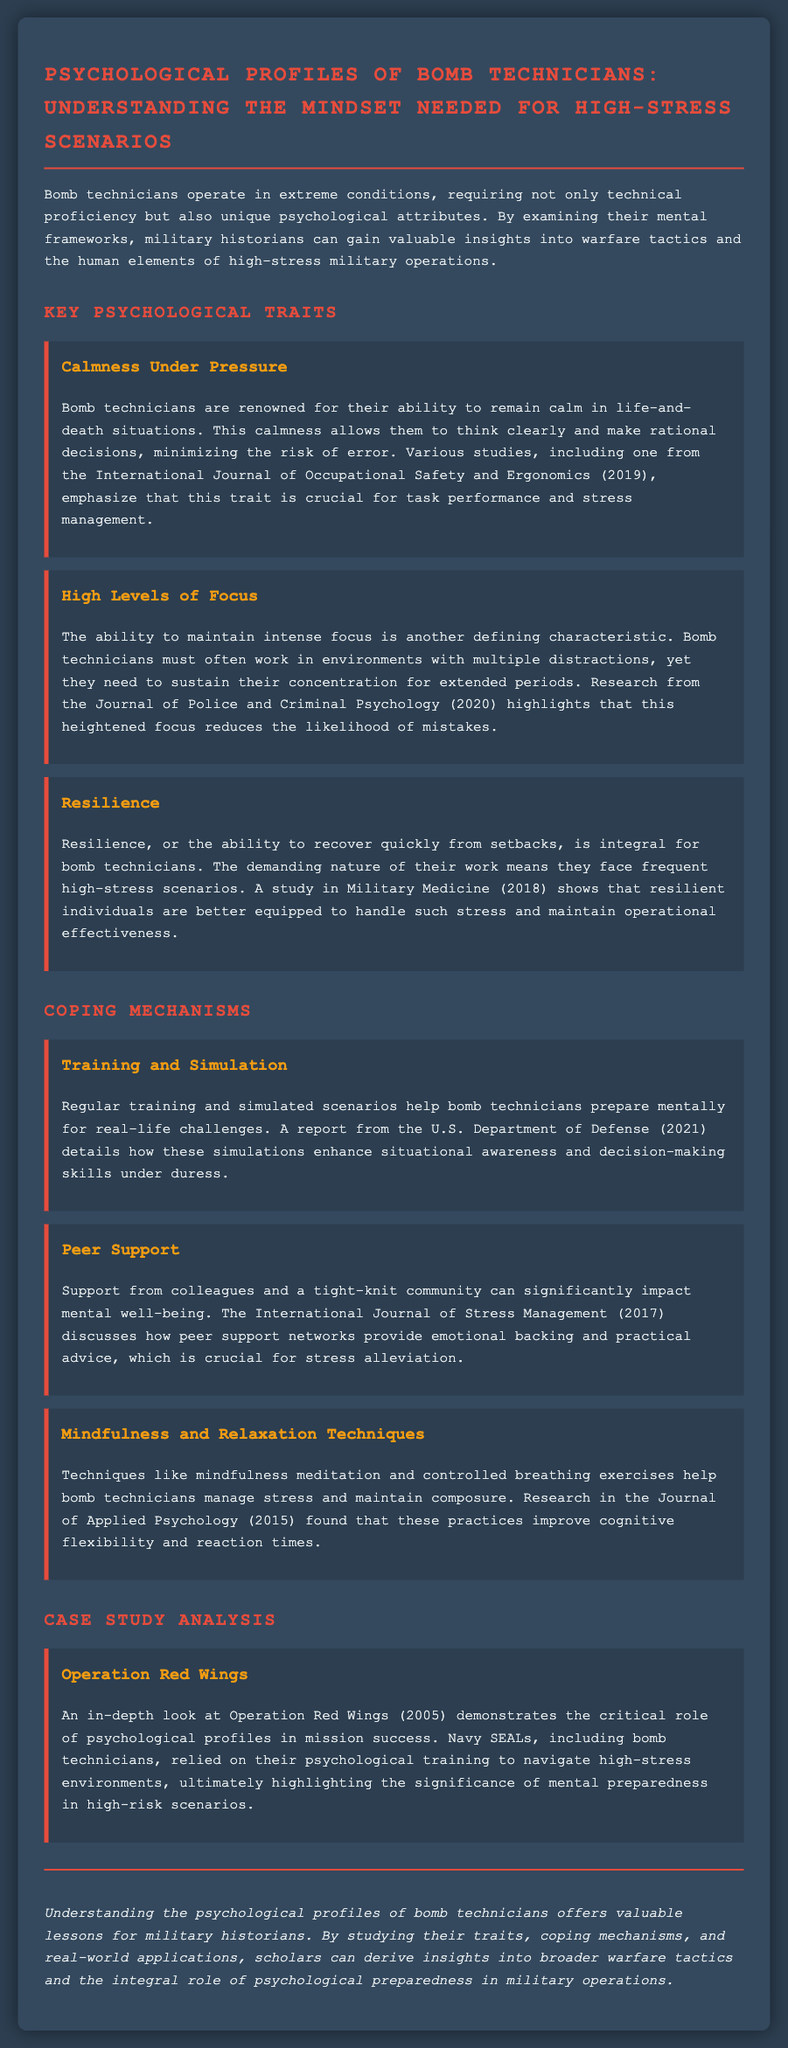what is the title of the document? The title is prominently displayed at the top of the document.
Answer: Psychological Profiles of Bomb Technicians: Understanding the Mindset Needed for High-Stress Scenarios what year was the study on calmness under pressure published? The year of publication is specified in the description of the study mentioned under the calmness trait.
Answer: 2019 which journal published the research on focus? The journal name is provided in the context of the high levels of focus trait.
Answer: Journal of Police and Criminal Psychology what is one coping mechanism mentioned in the document? A coping mechanism is listed under the section dedicated to coping mechanisms.
Answer: Training and Simulation name the operation analyzed in the case study. The operation is specified in the title of the case study section.
Answer: Operation Red Wings which trait enhances decision-making skills under duress? The trait is indicated in the description of the coping mechanism related to training and simulation.
Answer: Calmness Under Pressure how many key psychological traits are mentioned in the document? The document explicitly states the number of traits in the Key Psychological Traits section.
Answer: Three what color is used for the primary headings in the document? The color is described in the styling section for headings.
Answer: Red in what year was the study on resilience published? The publication year is noted in the content description related to the resilience trait.
Answer: 2018 